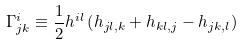<formula> <loc_0><loc_0><loc_500><loc_500>\Gamma ^ { i } _ { j k } \equiv \frac { 1 } { 2 } h ^ { i l } \left ( h _ { j l , k } + h _ { k l , j } - h _ { j k , l } \right )</formula> 